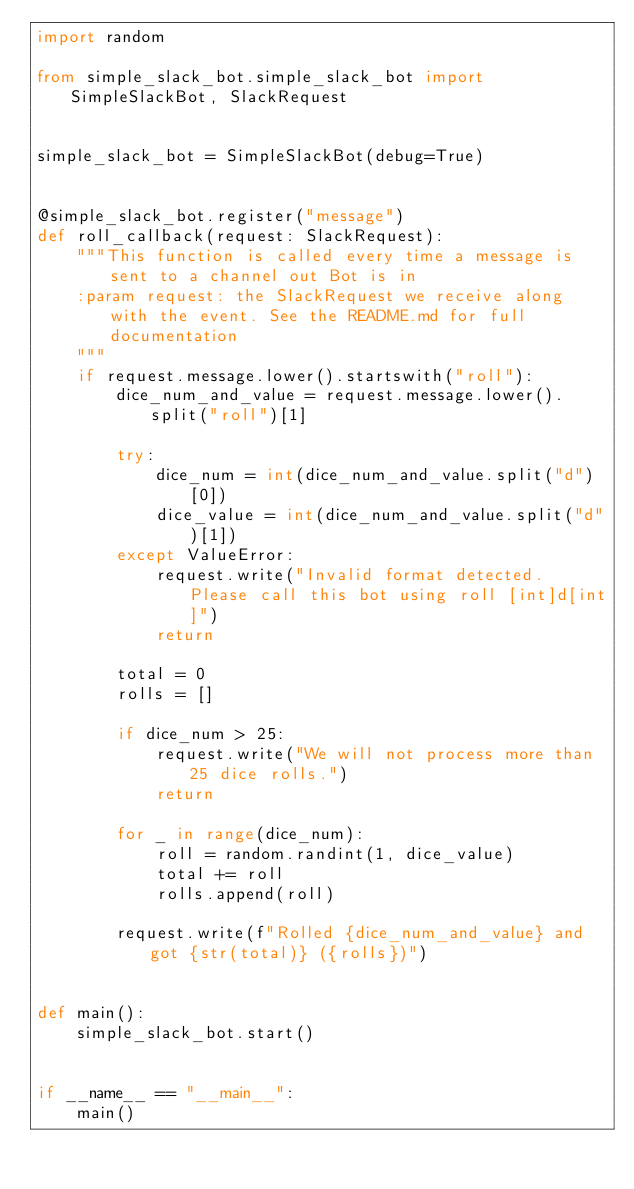Convert code to text. <code><loc_0><loc_0><loc_500><loc_500><_Python_>import random

from simple_slack_bot.simple_slack_bot import SimpleSlackBot, SlackRequest


simple_slack_bot = SimpleSlackBot(debug=True)


@simple_slack_bot.register("message")
def roll_callback(request: SlackRequest):
    """This function is called every time a message is sent to a channel out Bot is in
    :param request: the SlackRequest we receive along with the event. See the README.md for full documentation
    """
    if request.message.lower().startswith("roll"):
        dice_num_and_value = request.message.lower().split("roll")[1]

        try:
            dice_num = int(dice_num_and_value.split("d")[0])
            dice_value = int(dice_num_and_value.split("d")[1])
        except ValueError:
            request.write("Invalid format detected. Please call this bot using roll [int]d[int]")
            return

        total = 0
        rolls = []

        if dice_num > 25:
            request.write("We will not process more than 25 dice rolls.")
            return

        for _ in range(dice_num):
            roll = random.randint(1, dice_value)
            total += roll
            rolls.append(roll)

        request.write(f"Rolled {dice_num_and_value} and got {str(total)} ({rolls})")


def main():
    simple_slack_bot.start()


if __name__ == "__main__":
    main()
</code> 